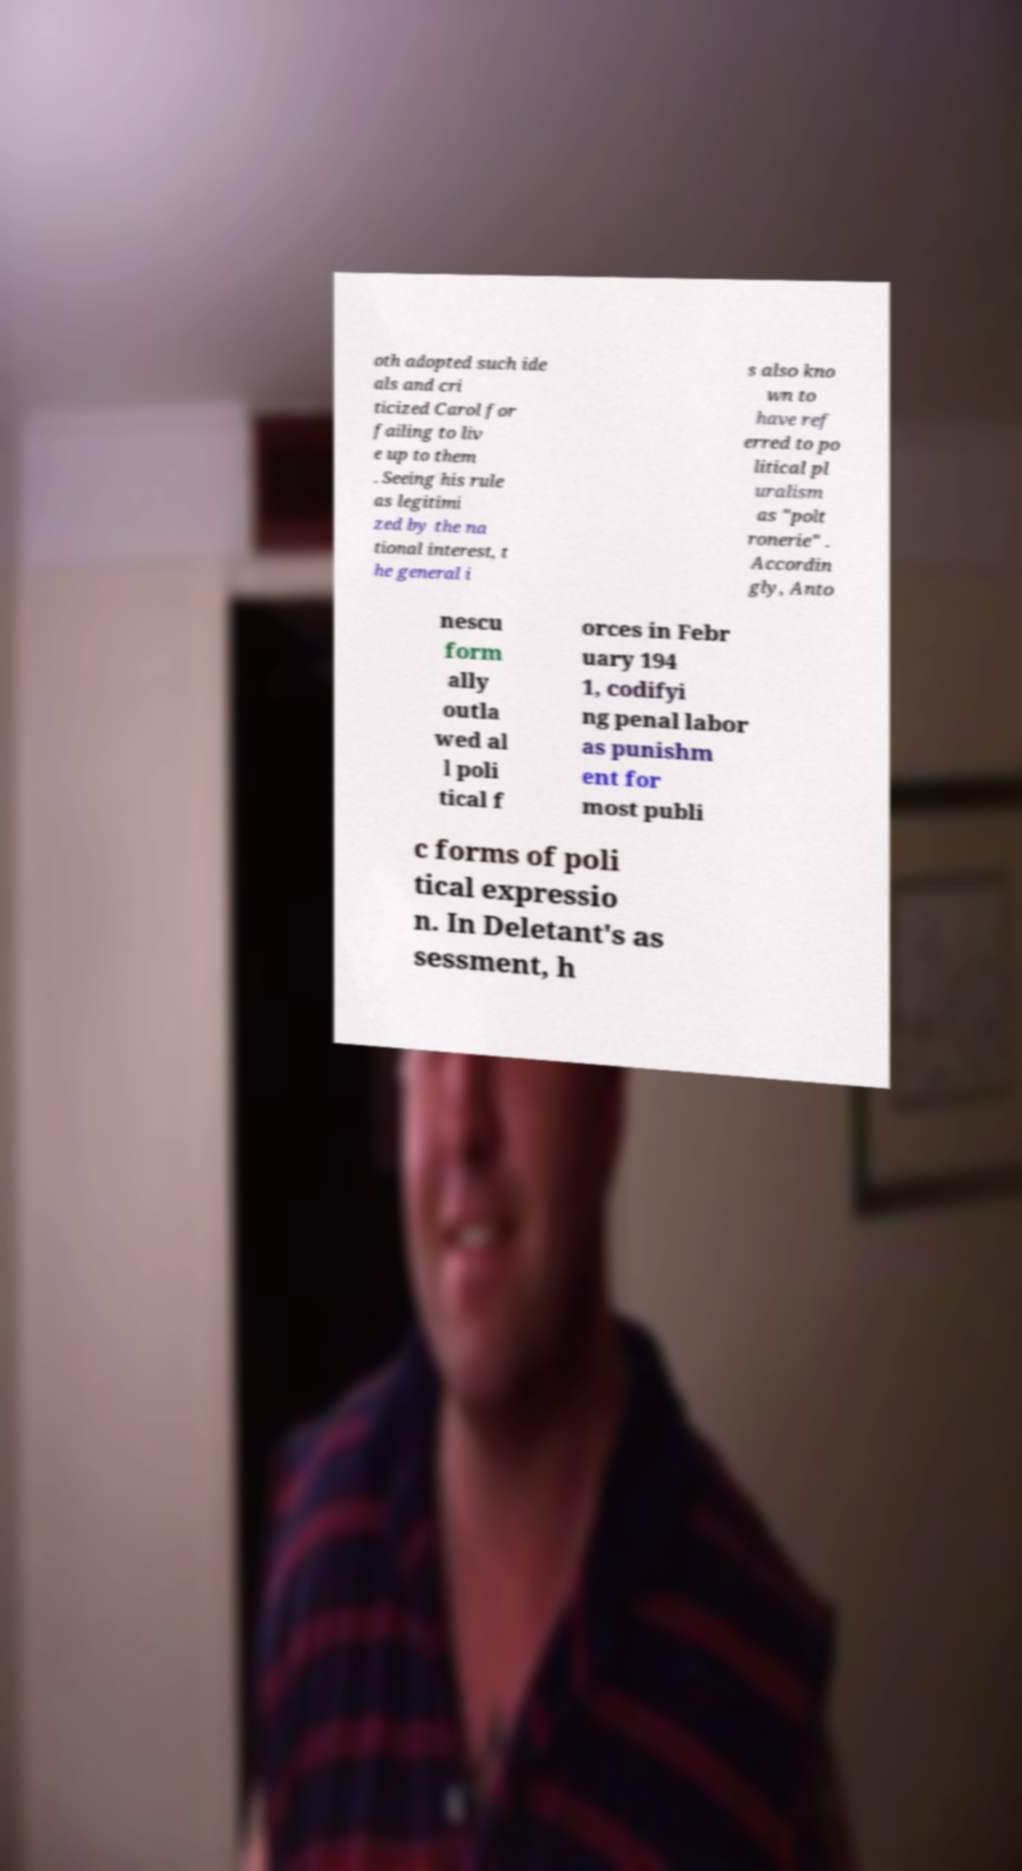Please read and relay the text visible in this image. What does it say? oth adopted such ide als and cri ticized Carol for failing to liv e up to them . Seeing his rule as legitimi zed by the na tional interest, t he general i s also kno wn to have ref erred to po litical pl uralism as "polt ronerie" . Accordin gly, Anto nescu form ally outla wed al l poli tical f orces in Febr uary 194 1, codifyi ng penal labor as punishm ent for most publi c forms of poli tical expressio n. In Deletant's as sessment, h 